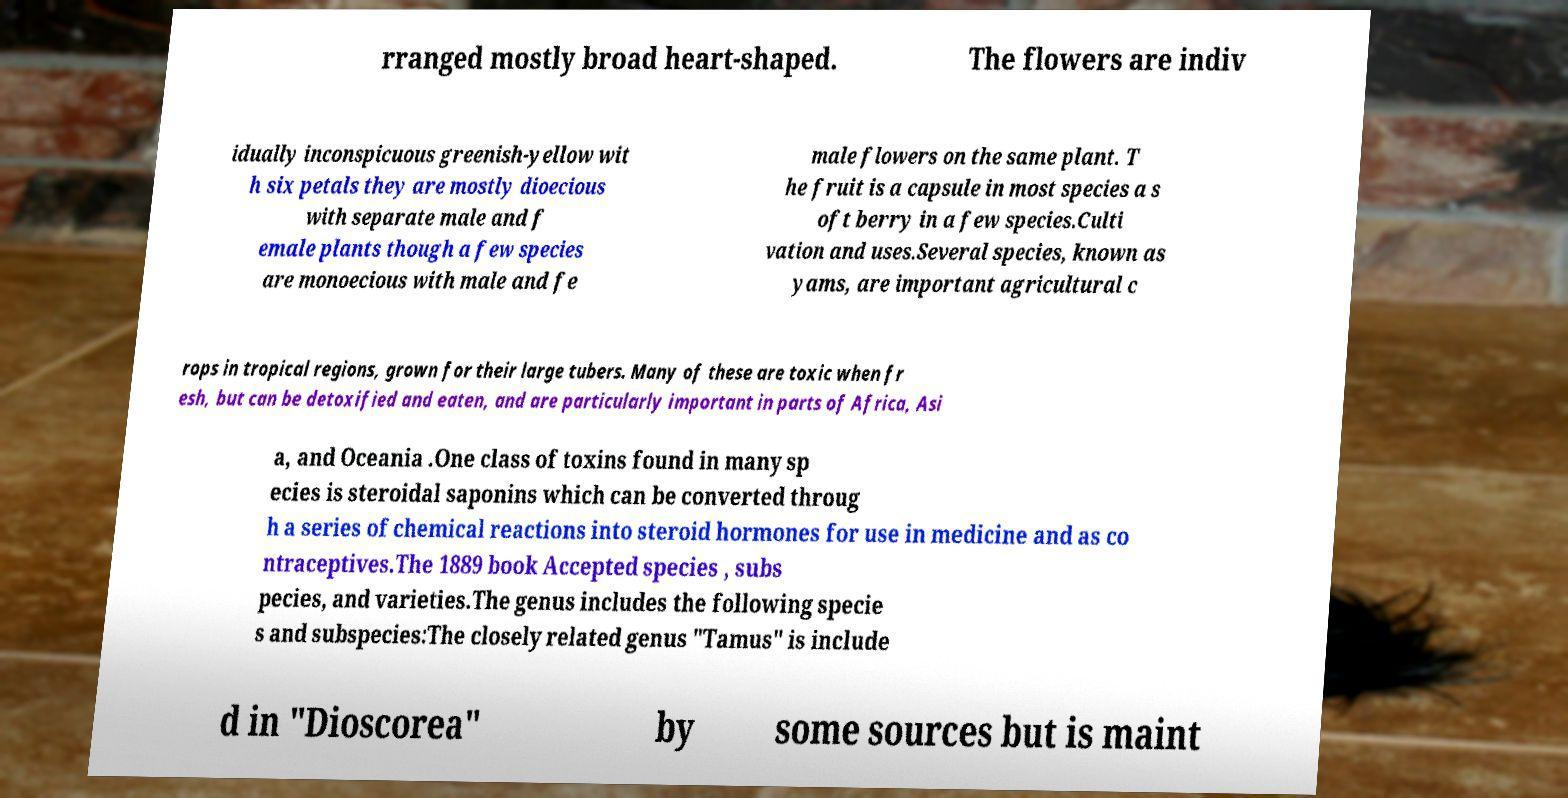There's text embedded in this image that I need extracted. Can you transcribe it verbatim? rranged mostly broad heart-shaped. The flowers are indiv idually inconspicuous greenish-yellow wit h six petals they are mostly dioecious with separate male and f emale plants though a few species are monoecious with male and fe male flowers on the same plant. T he fruit is a capsule in most species a s oft berry in a few species.Culti vation and uses.Several species, known as yams, are important agricultural c rops in tropical regions, grown for their large tubers. Many of these are toxic when fr esh, but can be detoxified and eaten, and are particularly important in parts of Africa, Asi a, and Oceania .One class of toxins found in many sp ecies is steroidal saponins which can be converted throug h a series of chemical reactions into steroid hormones for use in medicine and as co ntraceptives.The 1889 book Accepted species , subs pecies, and varieties.The genus includes the following specie s and subspecies:The closely related genus "Tamus" is include d in "Dioscorea" by some sources but is maint 